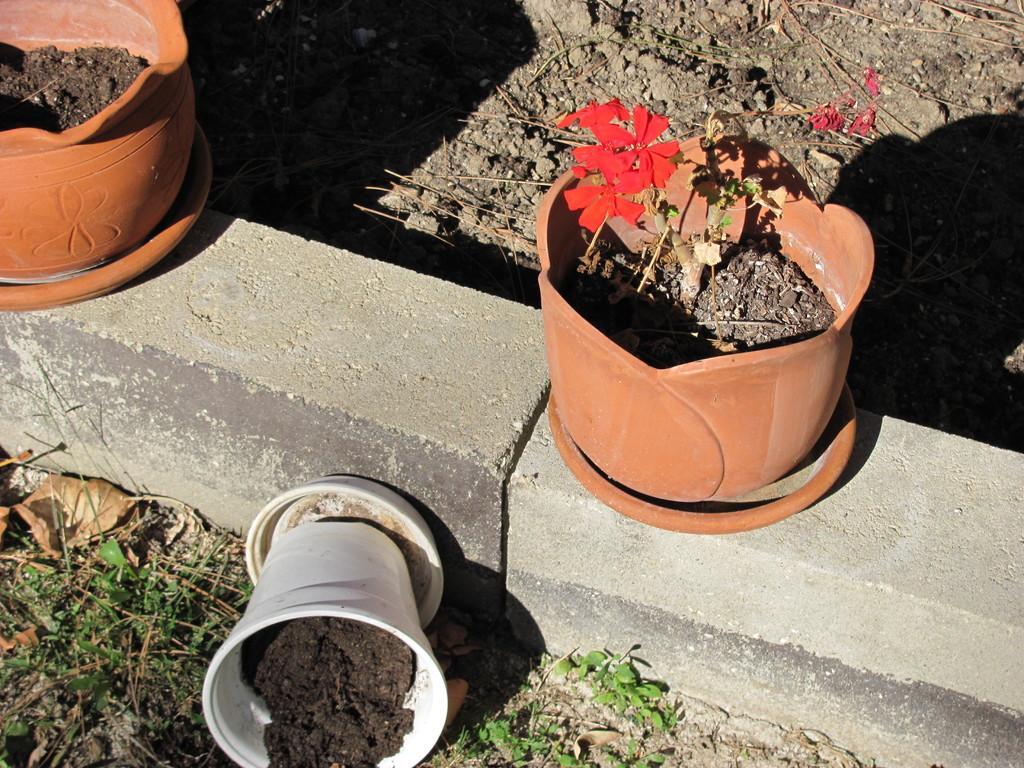In one or two sentences, can you explain what this image depicts? In this picture we can see the grass, stones, plant pots on plates with mud and flowers in it. In the background we can see stocks on the ground. 